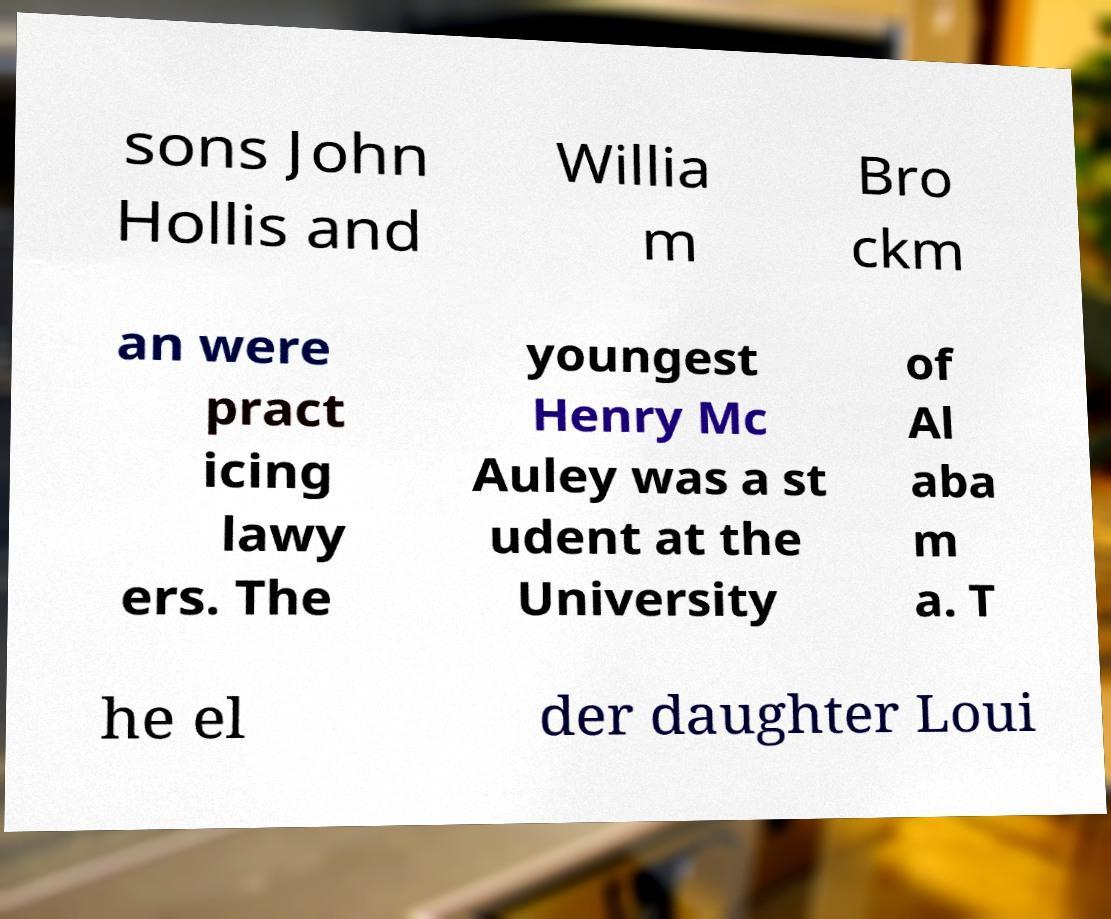I need the written content from this picture converted into text. Can you do that? sons John Hollis and Willia m Bro ckm an were pract icing lawy ers. The youngest Henry Mc Auley was a st udent at the University of Al aba m a. T he el der daughter Loui 